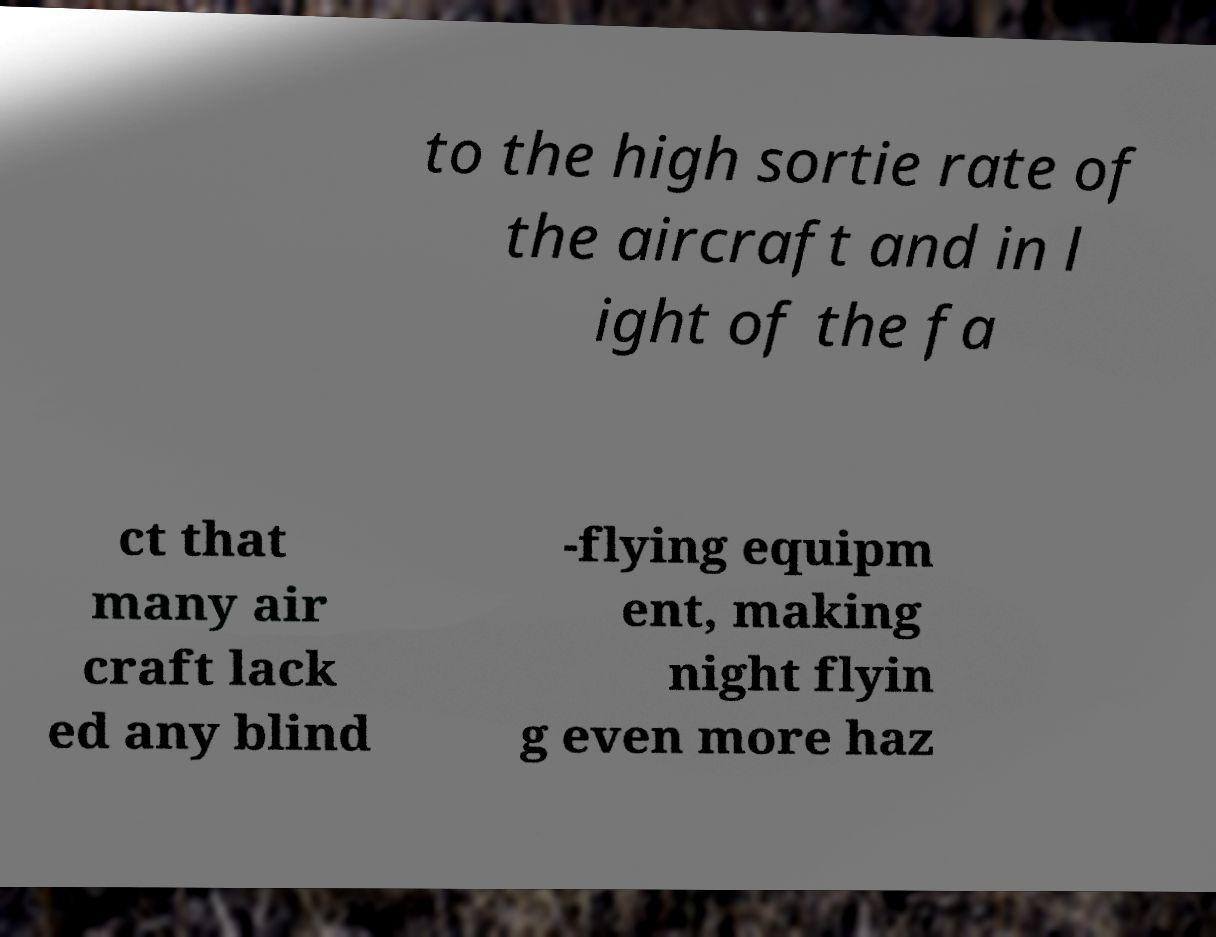Can you read and provide the text displayed in the image?This photo seems to have some interesting text. Can you extract and type it out for me? to the high sortie rate of the aircraft and in l ight of the fa ct that many air craft lack ed any blind -flying equipm ent, making night flyin g even more haz 